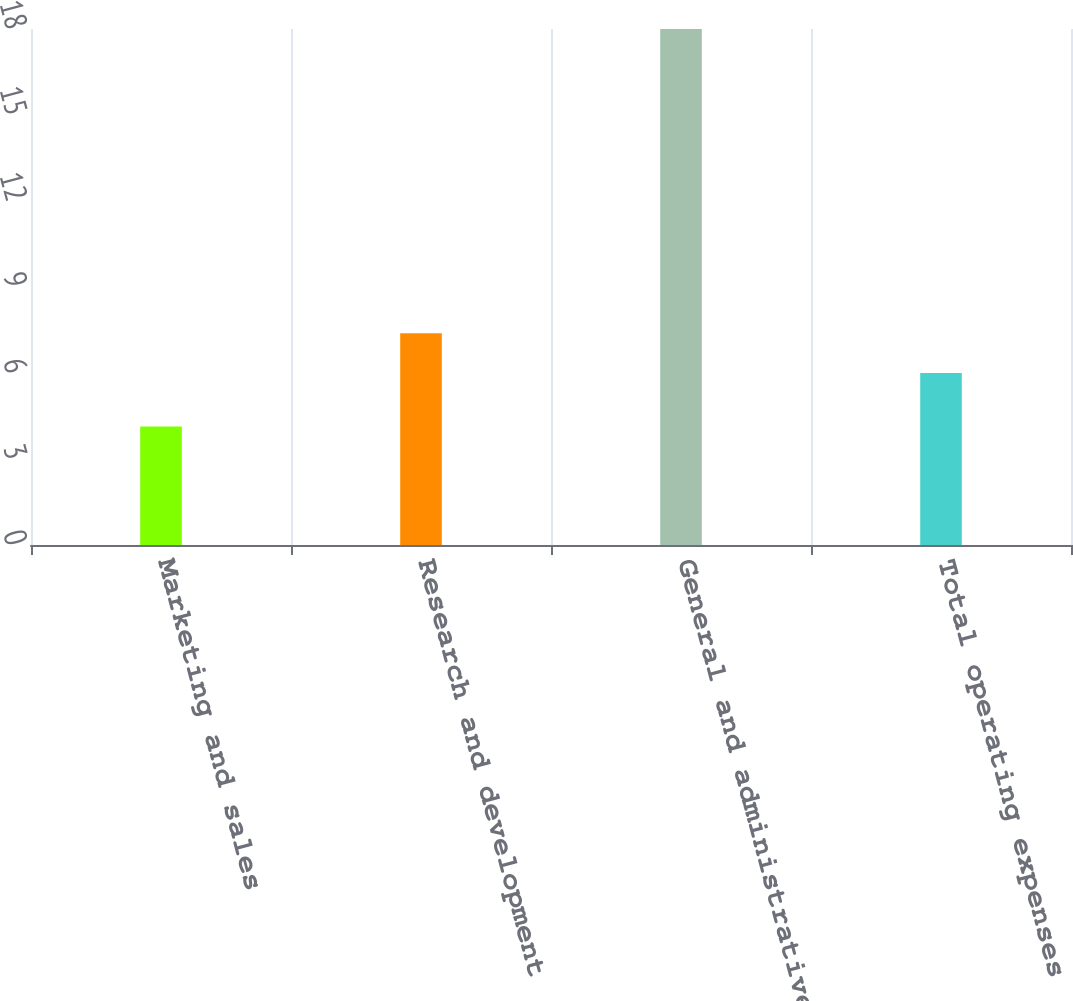<chart> <loc_0><loc_0><loc_500><loc_500><bar_chart><fcel>Marketing and sales<fcel>Research and development<fcel>General and administrative<fcel>Total operating expenses<nl><fcel>4.13<fcel>7.39<fcel>18<fcel>6<nl></chart> 